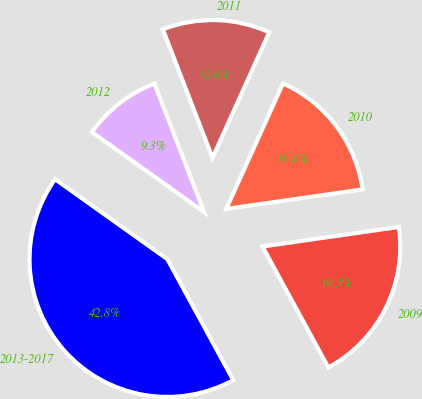<chart> <loc_0><loc_0><loc_500><loc_500><pie_chart><fcel>2009<fcel>2010<fcel>2011<fcel>2012<fcel>2013-2017<nl><fcel>19.33%<fcel>15.98%<fcel>12.63%<fcel>9.28%<fcel>42.79%<nl></chart> 